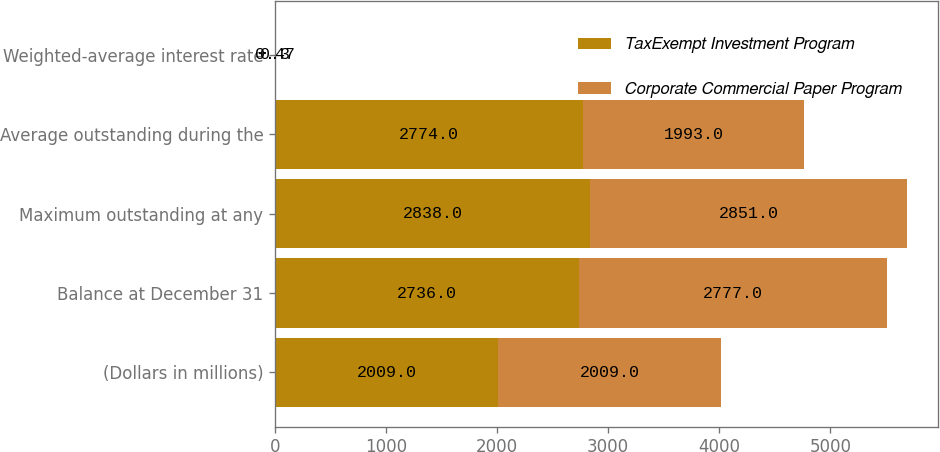Convert chart. <chart><loc_0><loc_0><loc_500><loc_500><stacked_bar_chart><ecel><fcel>(Dollars in millions)<fcel>Balance at December 31<fcel>Maximum outstanding at any<fcel>Average outstanding during the<fcel>Weighted-average interest rate<nl><fcel>TaxExempt Investment Program<fcel>2009<fcel>2736<fcel>2838<fcel>2774<fcel>0.47<nl><fcel>Corporate Commercial Paper Program<fcel>2009<fcel>2777<fcel>2851<fcel>1993<fcel>0.3<nl></chart> 